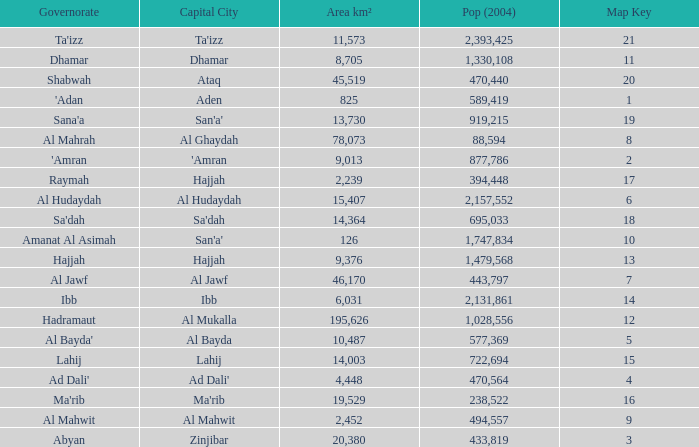How many Pop (2004) has a Governorate of al mahwit? 494557.0. 